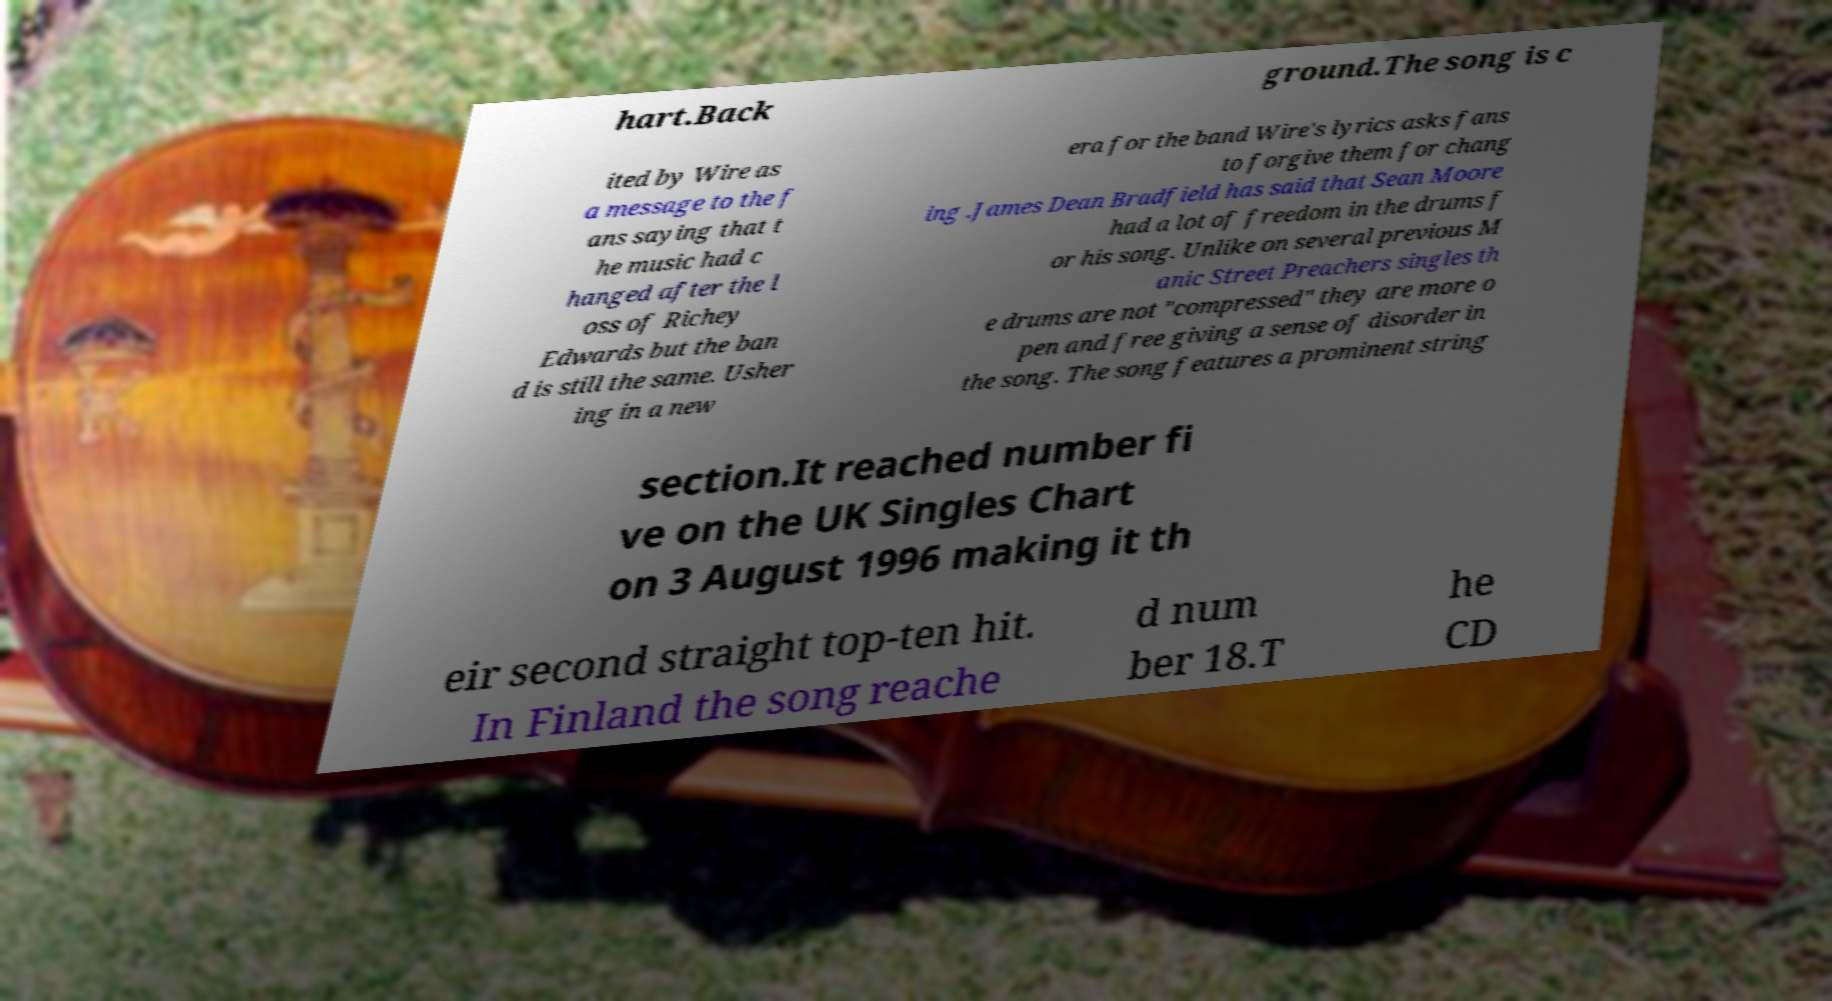Could you extract and type out the text from this image? hart.Back ground.The song is c ited by Wire as a message to the f ans saying that t he music had c hanged after the l oss of Richey Edwards but the ban d is still the same. Usher ing in a new era for the band Wire's lyrics asks fans to forgive them for chang ing .James Dean Bradfield has said that Sean Moore had a lot of freedom in the drums f or his song. Unlike on several previous M anic Street Preachers singles th e drums are not "compressed" they are more o pen and free giving a sense of disorder in the song. The song features a prominent string section.It reached number fi ve on the UK Singles Chart on 3 August 1996 making it th eir second straight top-ten hit. In Finland the song reache d num ber 18.T he CD 